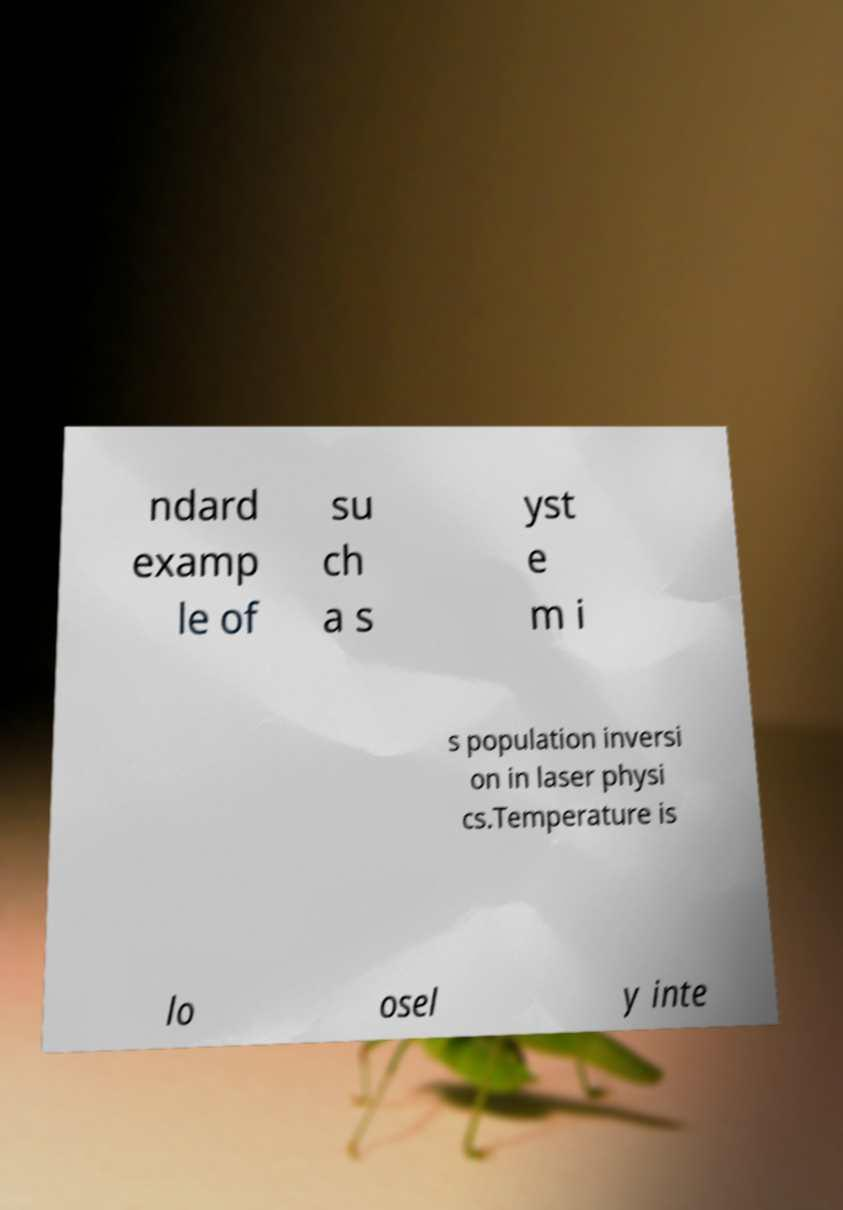Please identify and transcribe the text found in this image. ndard examp le of su ch a s yst e m i s population inversi on in laser physi cs.Temperature is lo osel y inte 